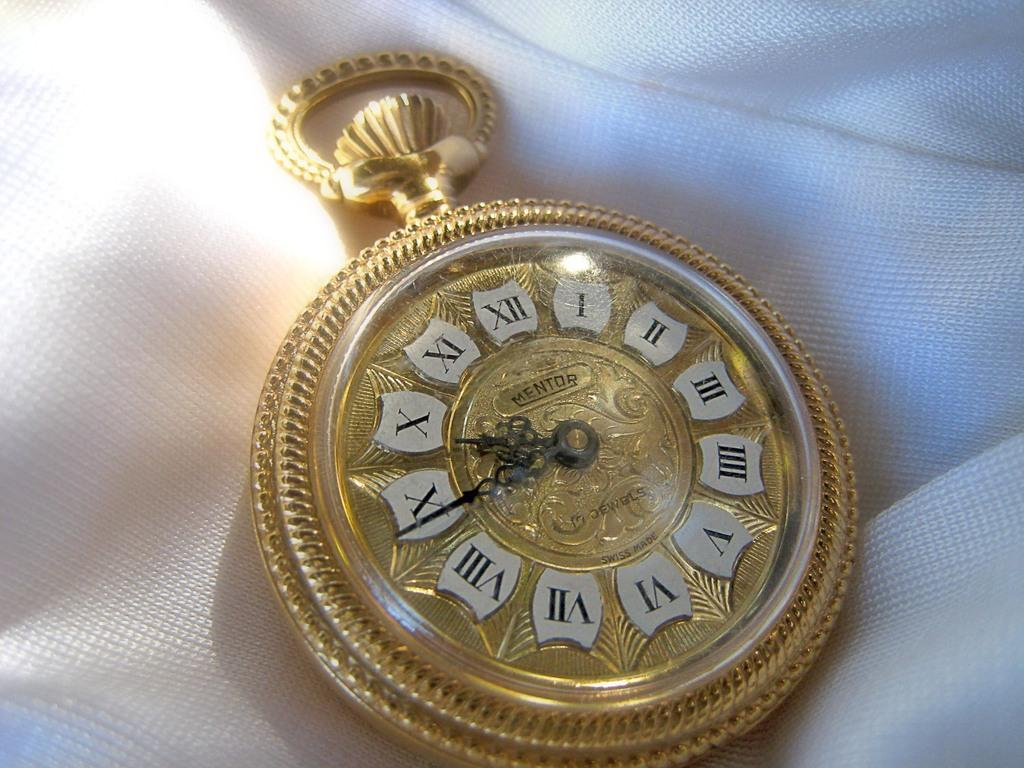What is the main object in the image? There is a pocket watch in the image. What is the pocket watch placed on? The pocket watch is on a white color cloth. How many pages are visible in the image? There are no pages present in the image; it features a pocket watch on a white color cloth. What type of net is used to catch the pocket watch in the image? There is no net present in the image, and the pocket watch is not being caught. 